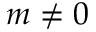<formula> <loc_0><loc_0><loc_500><loc_500>m \neq 0</formula> 